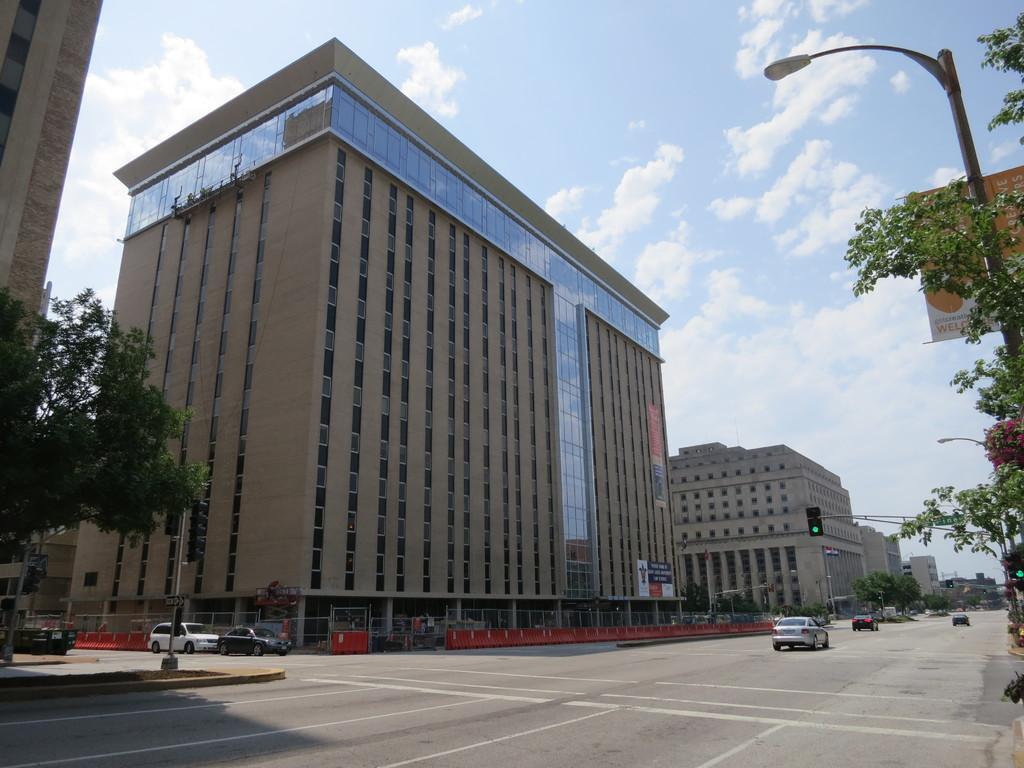In one or two sentences, can you explain what this image depicts? In the image in the center we can see buildings,trees,poles,banners,glass,wall,fence,traffic light and few vehicles on the road. In the background we can see the sky and clouds. 